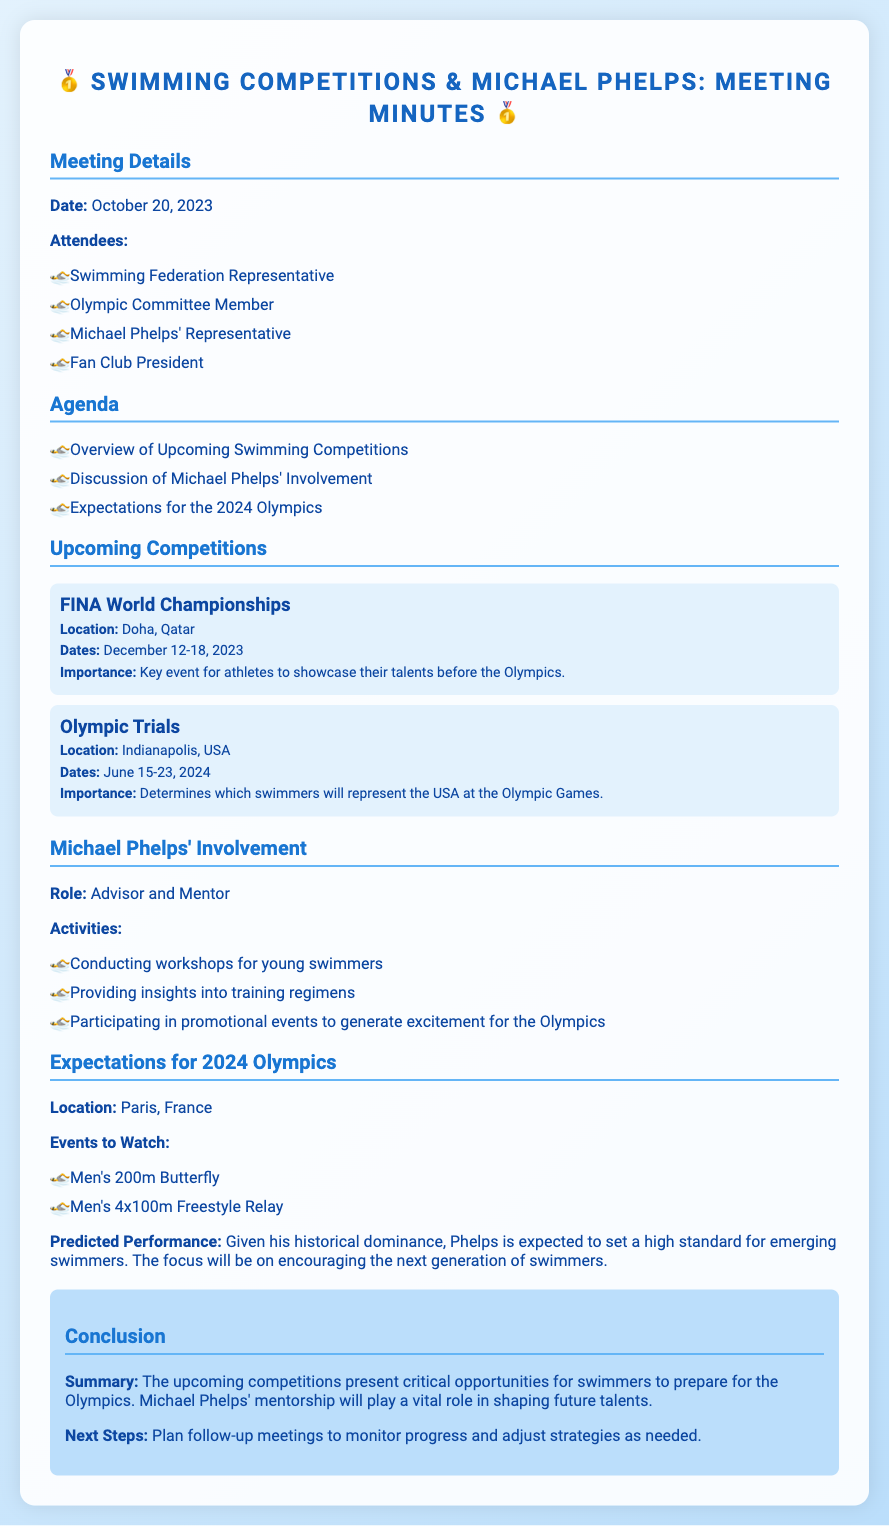What is the date of the meeting? The date of the meeting is specifically mentioned in the document.
Answer: October 20, 2023 Where is the FINA World Championships taking place? The location of the FINA World Championships is provided in the upcoming competitions section.
Answer: Doha, Qatar What is Michael Phelps' role in the upcoming competitions? The document states his involvement role clearly under Michael Phelps' Involvement section.
Answer: Advisor and Mentor What are the dates for the Olympic Trials? The dates for the Olympic Trials are listed for easy reference in the document.
Answer: June 15-23, 2024 Which events are predicted to be notable in the 2024 Olympics? The document lists specific events to watch under Expectations for 2024 Olympics.
Answer: Men's 200m Butterfly, Men's 4x100m Freestyle Relay What is the main focus of Michael Phelps' mentorship? The summary highlights the main focus of Phelps' involvement and mentorship.
Answer: Encouraging the next generation of swimmers What is emphasized as a critical opportunity for swimmers? The conclusion gives a clear summary of what is considered critical for swimmers.
Answer: Upcoming competitions What is the location of the 2024 Olympics? The document specifies the location of the upcoming Olympic Games.
Answer: Paris, France 